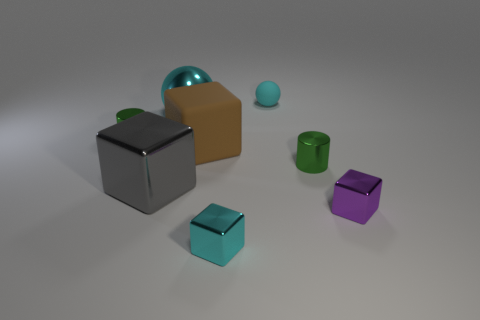Add 2 cyan metallic things. How many objects exist? 10 Subtract all cyan cubes. How many cubes are left? 3 Subtract all brown matte cubes. How many cubes are left? 3 Subtract 1 gray blocks. How many objects are left? 7 Subtract all spheres. How many objects are left? 6 Subtract 1 spheres. How many spheres are left? 1 Subtract all purple cylinders. Subtract all cyan cubes. How many cylinders are left? 2 Subtract all red spheres. How many brown cubes are left? 1 Subtract all tiny cyan balls. Subtract all metallic objects. How many objects are left? 1 Add 2 green metal objects. How many green metal objects are left? 4 